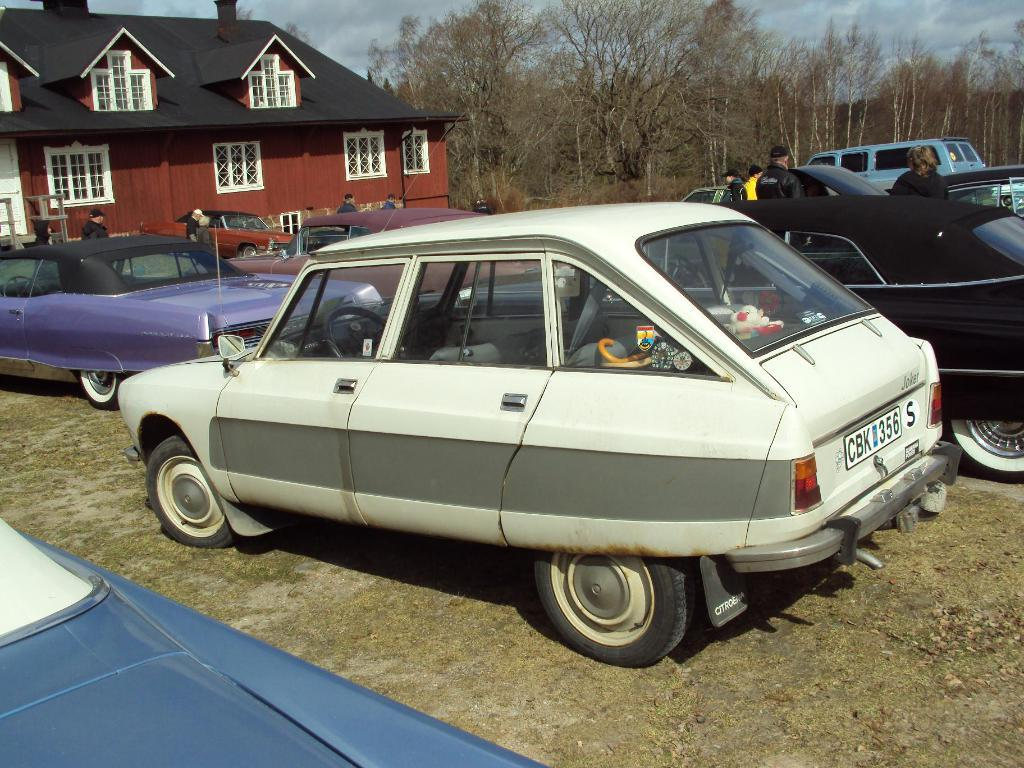Where was the image taken? The image was clicked outside. What can be seen in the center of the image? There is a group of cars and a group of persons in the center of the image. What is visible in the background of the image? There is sky, trees, and a house visible in the background of the image. How many wrens are sitting on the cars in the image? There are no wrens present in the image. What arithmetic problem can be solved using the number of oranges in the image? There are no oranges present in the image. 